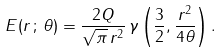Convert formula to latex. <formula><loc_0><loc_0><loc_500><loc_500>E ( r \, ; \, \theta ) = \frac { 2 Q } { \sqrt { \pi } \, r ^ { 2 } } \, \gamma \left ( \frac { 3 } { 2 } , \frac { r ^ { 2 } } { 4 \theta } \right ) .</formula> 